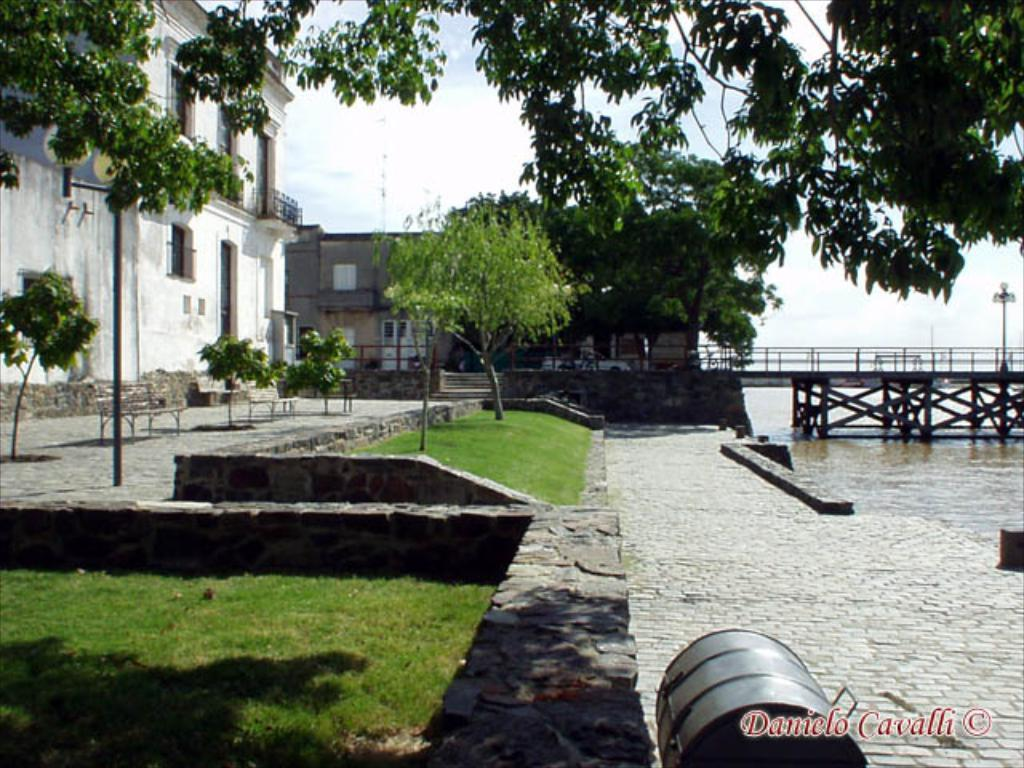What type of natural elements can be seen in the image? There are trees in the image. What type of man-made structures are present in the image? There are buildings and a bridge on the right side of the image. What objects are present for people to use in the image? There are poles and benches in the image. What is visible at the bottom of the image? There is water at the bottom of the image. What type of egg is visible on the bridge in the image? There is no egg present on the bridge or anywhere else in the image. What type of glass is used to construct the buildings in the image? The buildings in the image are not described in terms of the materials used to construct them, so it is not possible to determine if glass is used. 